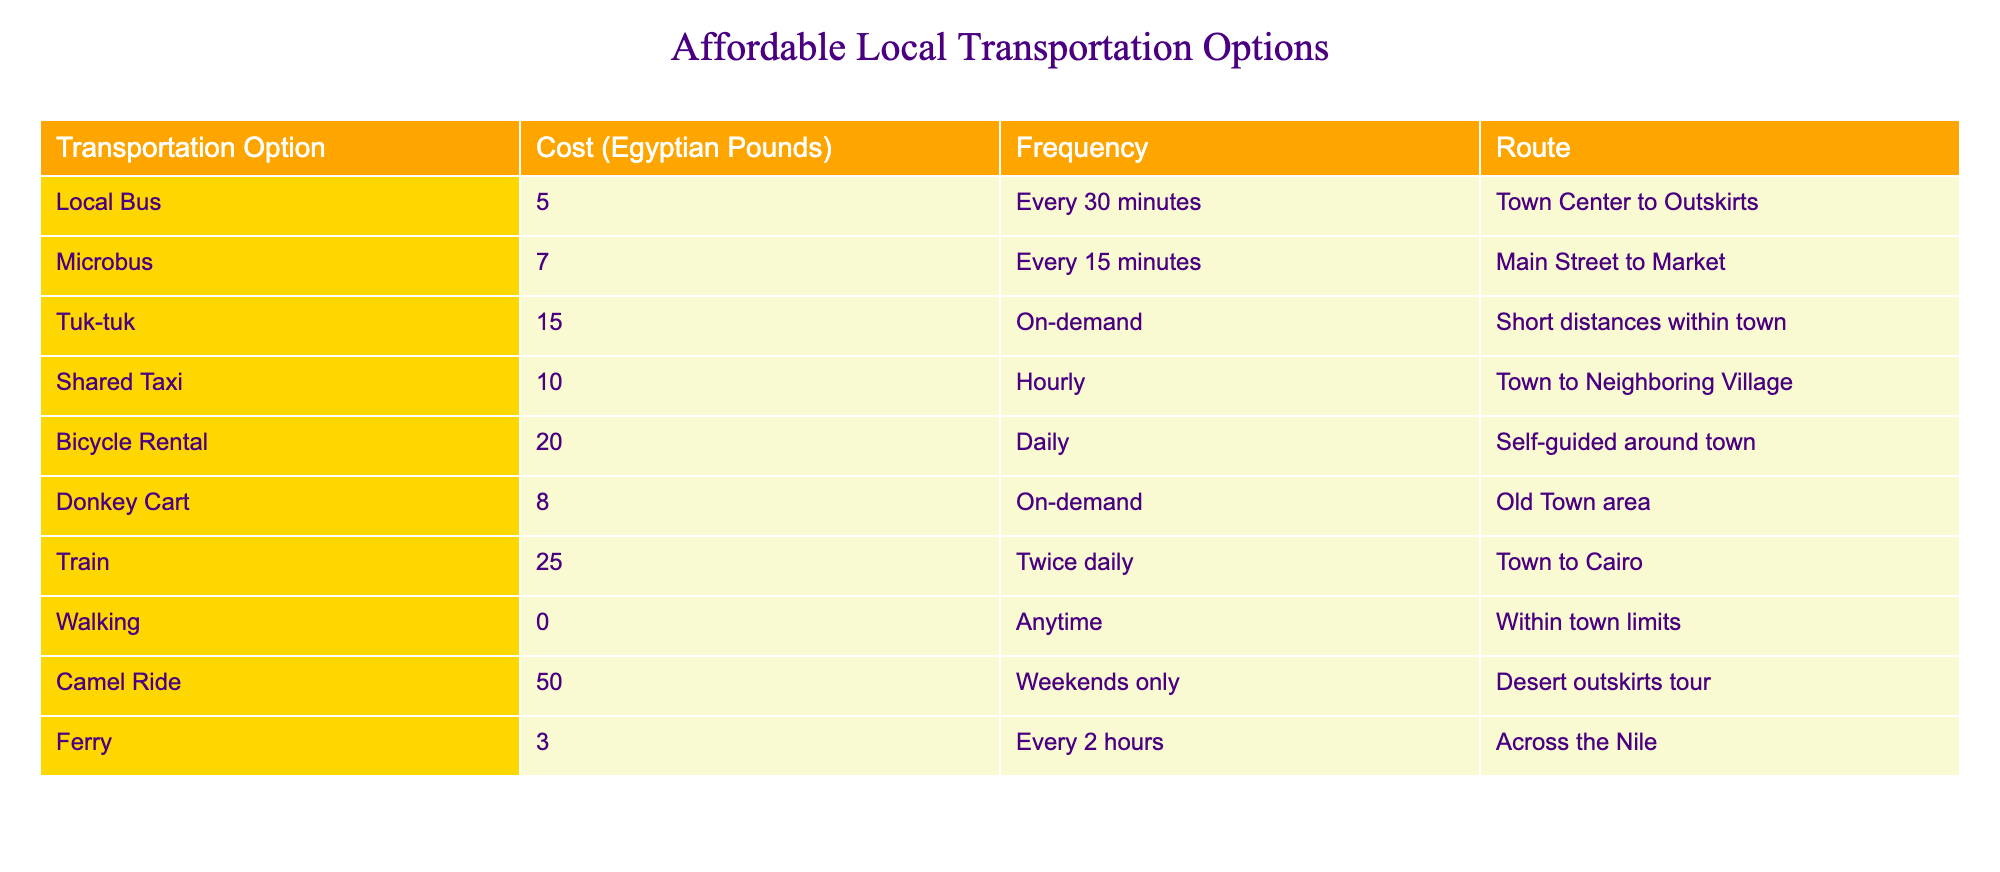What is the cost of taking a local bus? From the table, the cost of taking a local bus is clearly listed in the "Cost (Egyptian Pounds)" column next to "Local Bus." It shows the value as 5.
Answer: 5 How often do microbuses run? The frequency of microbuses is found in the "Frequency" column. It indicates that microbuses run every 15 minutes.
Answer: Every 15 minutes Is it free to walk within town limits? Looking at the table in the "Cost (Egyptian Pounds)" column for "Walking," it shows the cost as 0 Egyptian Pounds, which confirms that walking is free.
Answer: Yes What is the average cost of transportation options starting from the cheapest (Ferry) to the most expensive (Camel Ride)? First, sum the costs of all transportation options: 5 + 7 + 15 + 10 + 20 + 8 + 25 + 0 + 50 + 3 = 143. There are 10 options, so the average cost is 143 divided by 10, which equals 14.3.
Answer: 14.3 Can you reach Cairo by train? The table specifies a route "Town to Cairo" under the "Train" transportation option, confirming that you can reach Cairo by train.
Answer: Yes Which option is the most expensive transportation method listed? In the "Cost (Egyptian Pounds)" column, the highest value is next to "Camel Ride," which is 50, indicating it as the most expensive option.
Answer: Camel Ride What is the difference in cost between taking a shared taxi and a tuk-tuk? The cost of a shared taxi is listed as 10, and the cost of a tuk-tuk is 15. To find the difference, subtract the cost of the shared taxi from that of the tuk-tuk: 15 - 10 = 5.
Answer: 5 How frequently does the ferry operate? The table indicates that the ferry operates every 2 hours, as stated under the "Frequency" column.
Answer: Every 2 hours Is it possible to rent a bicycle for less than 20 Egyptian Pounds? The "Cost (Egyptian Pounds)" column shows that Bicycle Rental costs 20, which means renting a bicycle is not less than 20 Egyptian Pounds.
Answer: No 